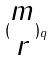<formula> <loc_0><loc_0><loc_500><loc_500>( \begin{matrix} m \\ r \end{matrix} ) _ { q }</formula> 